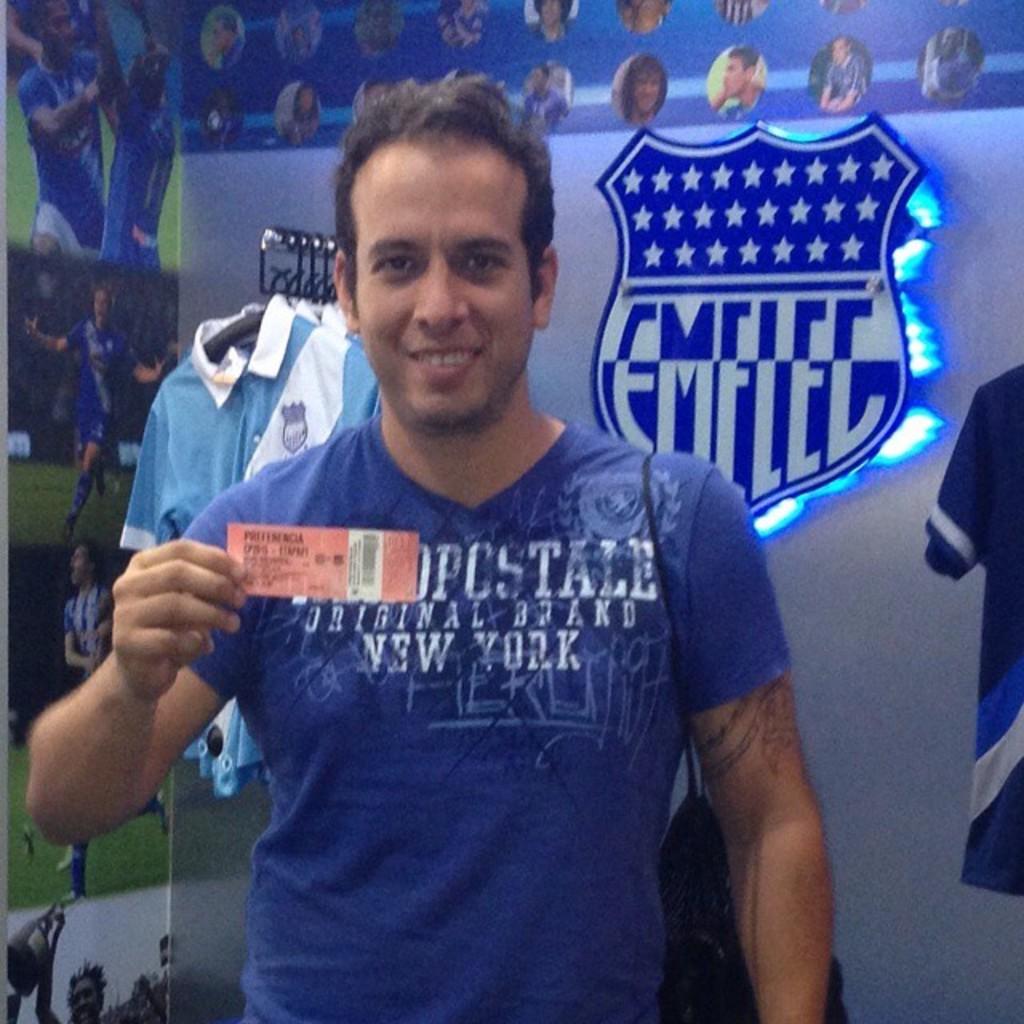What city is named on the guy's shirt?
Your answer should be compact. New york. What location is on his shirt?
Your response must be concise. New york. 